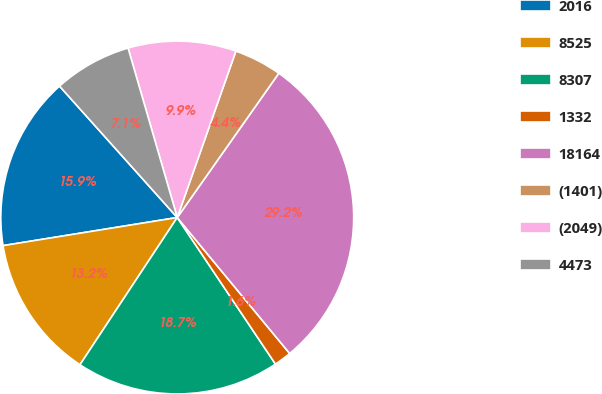Convert chart to OTSL. <chart><loc_0><loc_0><loc_500><loc_500><pie_chart><fcel>2016<fcel>8525<fcel>8307<fcel>1332<fcel>18164<fcel>(1401)<fcel>(2049)<fcel>4473<nl><fcel>15.92%<fcel>13.16%<fcel>18.69%<fcel>1.6%<fcel>29.24%<fcel>4.37%<fcel>9.89%<fcel>7.13%<nl></chart> 